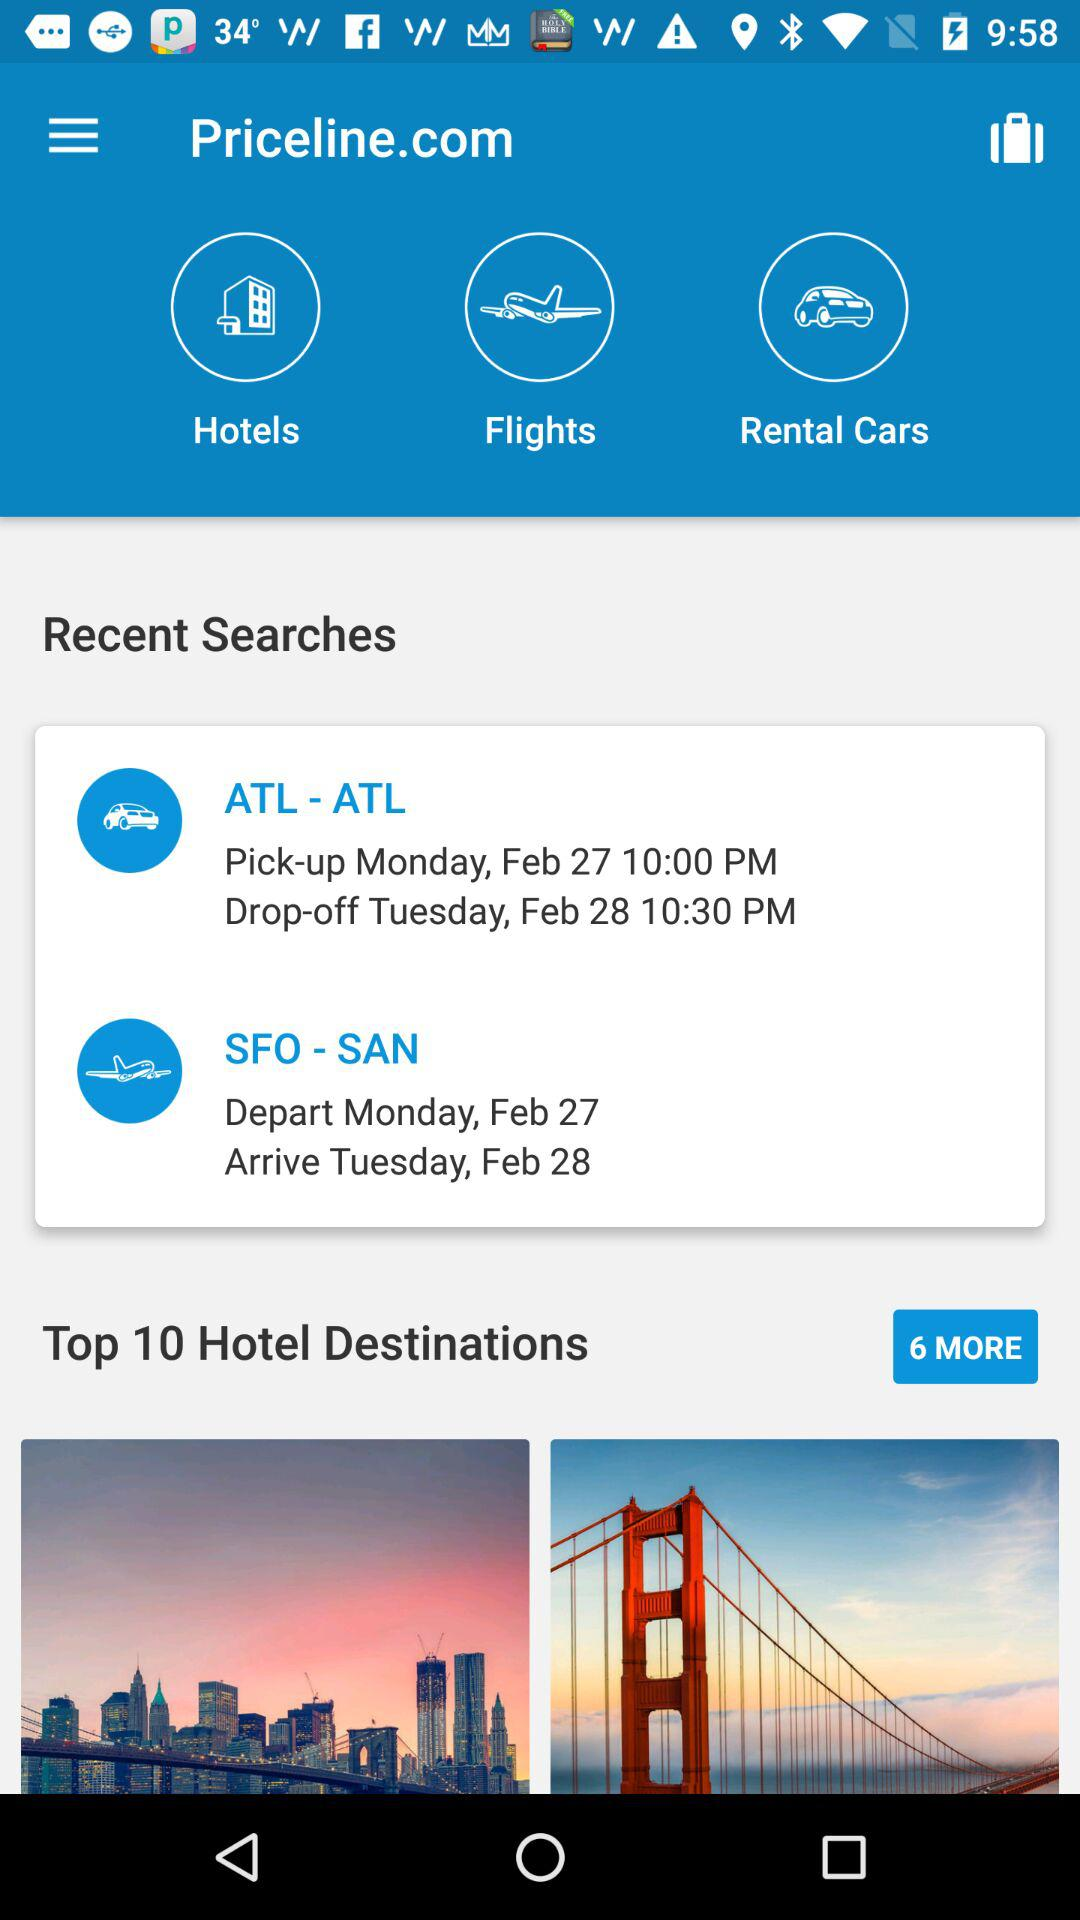What are the pick-up and drop-off details for ATL? The pick-up and drop-off details are Monday, February 27 at 10:00 PM and Tuesday, February 28 at 10:30 PM, respectively. 